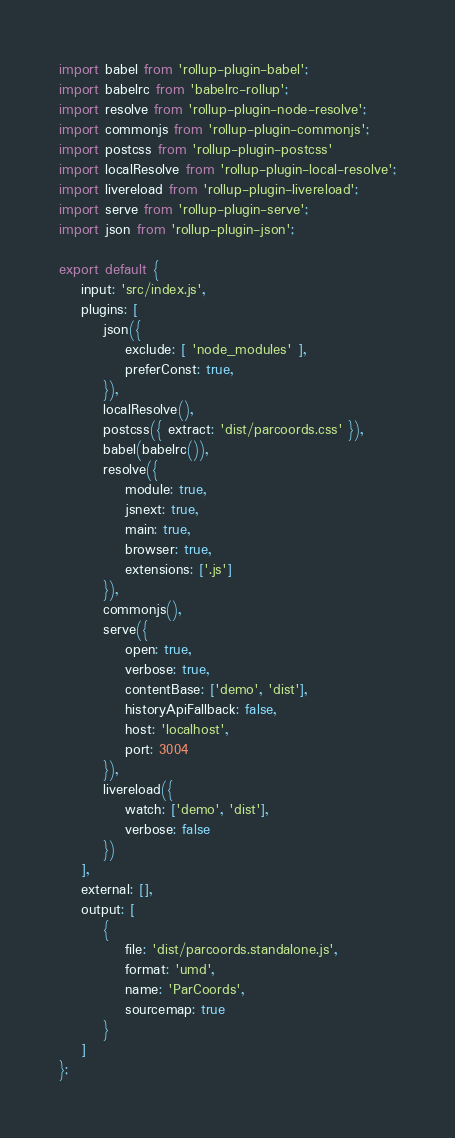<code> <loc_0><loc_0><loc_500><loc_500><_JavaScript_>import babel from 'rollup-plugin-babel';
import babelrc from 'babelrc-rollup';
import resolve from 'rollup-plugin-node-resolve';
import commonjs from 'rollup-plugin-commonjs';
import postcss from 'rollup-plugin-postcss'
import localResolve from 'rollup-plugin-local-resolve';
import livereload from 'rollup-plugin-livereload';
import serve from 'rollup-plugin-serve';
import json from 'rollup-plugin-json';

export default {
    input: 'src/index.js',
    plugins: [
        json({
            exclude: [ 'node_modules' ],
            preferConst: true,
        }),
        localResolve(),
        postcss({ extract: 'dist/parcoords.css' }),
        babel(babelrc()),
        resolve({
            module: true,
            jsnext: true,
            main: true,
            browser: true,
            extensions: ['.js']
        }),
        commonjs(),
        serve({
            open: true,
            verbose: true,
            contentBase: ['demo', 'dist'],
            historyApiFallback: false,
            host: 'localhost',
            port: 3004
        }),
        livereload({
            watch: ['demo', 'dist'],
            verbose: false
        })
    ],
    external: [],
    output: [
        {
            file: 'dist/parcoords.standalone.js',
            format: 'umd',
            name: 'ParCoords',
            sourcemap: true
        }
    ]
};
</code> 